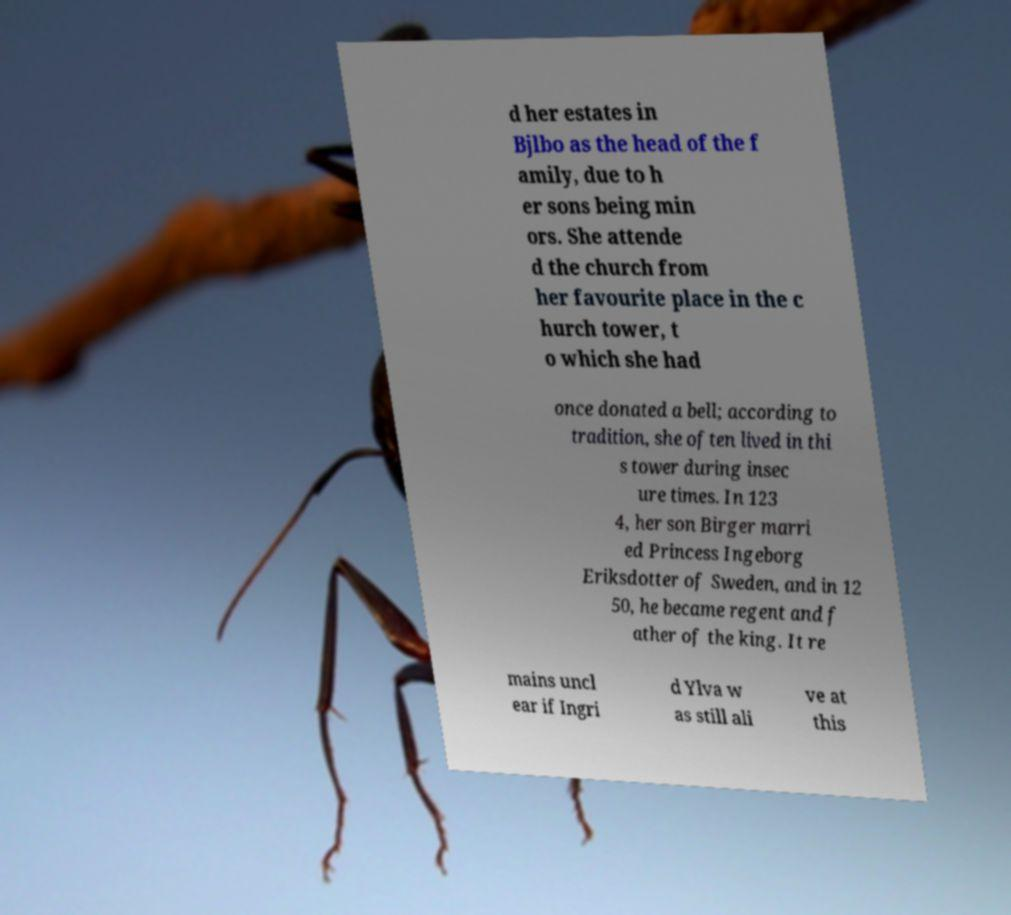For documentation purposes, I need the text within this image transcribed. Could you provide that? d her estates in Bjlbo as the head of the f amily, due to h er sons being min ors. She attende d the church from her favourite place in the c hurch tower, t o which she had once donated a bell; according to tradition, she often lived in thi s tower during insec ure times. In 123 4, her son Birger marri ed Princess Ingeborg Eriksdotter of Sweden, and in 12 50, he became regent and f ather of the king. It re mains uncl ear if Ingri d Ylva w as still ali ve at this 